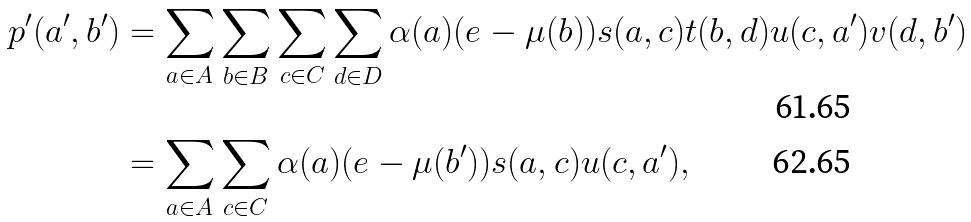Convert formula to latex. <formula><loc_0><loc_0><loc_500><loc_500>p ^ { \prime } ( a ^ { \prime } , b ^ { \prime } ) & = \sum _ { a \in A } \sum _ { b \in B } \sum _ { c \in C } \sum _ { d \in D } \alpha ( a ) ( e - \mu ( b ) ) s ( a , c ) t ( b , d ) u ( c , a ^ { \prime } ) v ( d , b ^ { \prime } ) \\ & = \sum _ { a \in A } \sum _ { c \in C } \alpha ( a ) ( e - \mu ( b ^ { \prime } ) ) s ( a , c ) u ( c , a ^ { \prime } ) ,</formula> 